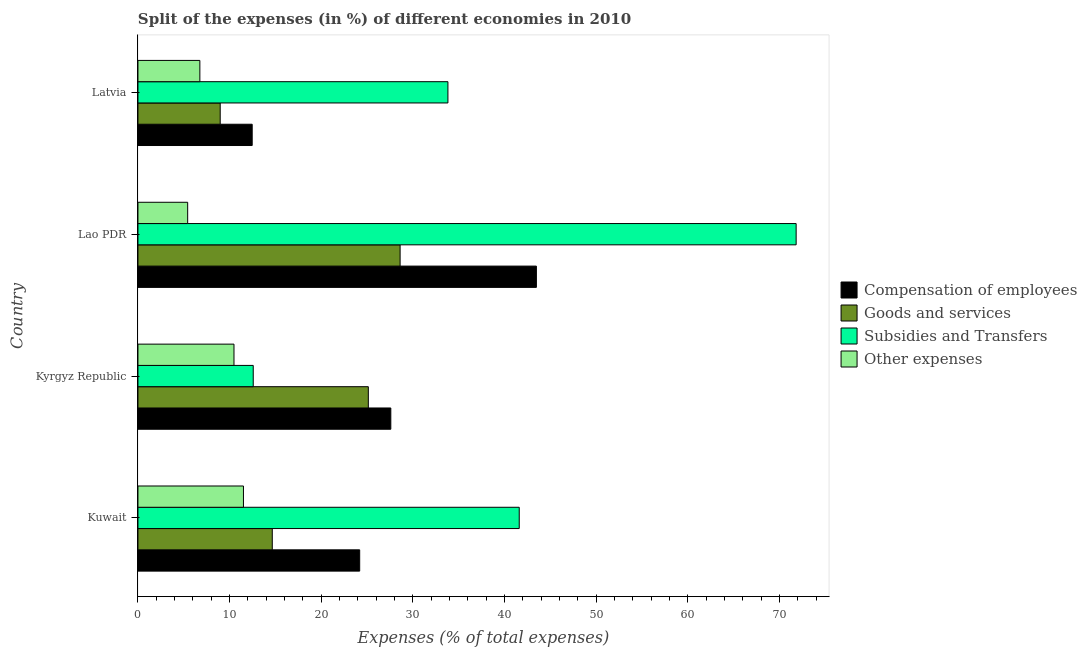How many groups of bars are there?
Provide a succinct answer. 4. Are the number of bars per tick equal to the number of legend labels?
Ensure brevity in your answer.  Yes. How many bars are there on the 3rd tick from the top?
Offer a very short reply. 4. How many bars are there on the 4th tick from the bottom?
Your response must be concise. 4. What is the label of the 4th group of bars from the top?
Provide a short and direct response. Kuwait. What is the percentage of amount spent on compensation of employees in Latvia?
Your answer should be very brief. 12.46. Across all countries, what is the maximum percentage of amount spent on goods and services?
Make the answer very short. 28.6. Across all countries, what is the minimum percentage of amount spent on compensation of employees?
Your answer should be very brief. 12.46. In which country was the percentage of amount spent on other expenses maximum?
Give a very brief answer. Kuwait. In which country was the percentage of amount spent on subsidies minimum?
Provide a short and direct response. Kyrgyz Republic. What is the total percentage of amount spent on other expenses in the graph?
Your answer should be very brief. 34.16. What is the difference between the percentage of amount spent on subsidies in Kyrgyz Republic and that in Lao PDR?
Provide a short and direct response. -59.23. What is the difference between the percentage of amount spent on other expenses in Kuwait and the percentage of amount spent on compensation of employees in Lao PDR?
Provide a short and direct response. -31.96. What is the average percentage of amount spent on goods and services per country?
Make the answer very short. 19.34. What is the difference between the percentage of amount spent on other expenses and percentage of amount spent on goods and services in Kyrgyz Republic?
Give a very brief answer. -14.66. What is the ratio of the percentage of amount spent on compensation of employees in Kyrgyz Republic to that in Lao PDR?
Keep it short and to the point. 0.64. Is the difference between the percentage of amount spent on subsidies in Kuwait and Latvia greater than the difference between the percentage of amount spent on other expenses in Kuwait and Latvia?
Provide a short and direct response. Yes. What is the difference between the highest and the second highest percentage of amount spent on compensation of employees?
Ensure brevity in your answer.  15.88. What is the difference between the highest and the lowest percentage of amount spent on goods and services?
Your response must be concise. 19.63. In how many countries, is the percentage of amount spent on other expenses greater than the average percentage of amount spent on other expenses taken over all countries?
Offer a terse response. 2. Is the sum of the percentage of amount spent on goods and services in Kuwait and Kyrgyz Republic greater than the maximum percentage of amount spent on compensation of employees across all countries?
Make the answer very short. No. What does the 4th bar from the top in Kyrgyz Republic represents?
Provide a short and direct response. Compensation of employees. What does the 4th bar from the bottom in Latvia represents?
Keep it short and to the point. Other expenses. How many countries are there in the graph?
Provide a succinct answer. 4. Are the values on the major ticks of X-axis written in scientific E-notation?
Your answer should be very brief. No. Does the graph contain grids?
Give a very brief answer. No. Where does the legend appear in the graph?
Provide a succinct answer. Center right. How are the legend labels stacked?
Offer a very short reply. Vertical. What is the title of the graph?
Give a very brief answer. Split of the expenses (in %) of different economies in 2010. What is the label or title of the X-axis?
Ensure brevity in your answer.  Expenses (% of total expenses). What is the label or title of the Y-axis?
Your answer should be very brief. Country. What is the Expenses (% of total expenses) of Compensation of employees in Kuwait?
Your response must be concise. 24.19. What is the Expenses (% of total expenses) in Goods and services in Kuwait?
Give a very brief answer. 14.65. What is the Expenses (% of total expenses) in Subsidies and Transfers in Kuwait?
Keep it short and to the point. 41.6. What is the Expenses (% of total expenses) in Other expenses in Kuwait?
Offer a very short reply. 11.51. What is the Expenses (% of total expenses) of Compensation of employees in Kyrgyz Republic?
Provide a succinct answer. 27.59. What is the Expenses (% of total expenses) in Goods and services in Kyrgyz Republic?
Your answer should be very brief. 25.13. What is the Expenses (% of total expenses) of Subsidies and Transfers in Kyrgyz Republic?
Provide a succinct answer. 12.58. What is the Expenses (% of total expenses) of Other expenses in Kyrgyz Republic?
Your answer should be compact. 10.48. What is the Expenses (% of total expenses) in Compensation of employees in Lao PDR?
Your answer should be very brief. 43.47. What is the Expenses (% of total expenses) of Goods and services in Lao PDR?
Give a very brief answer. 28.6. What is the Expenses (% of total expenses) of Subsidies and Transfers in Lao PDR?
Provide a succinct answer. 71.81. What is the Expenses (% of total expenses) of Other expenses in Lao PDR?
Offer a very short reply. 5.42. What is the Expenses (% of total expenses) in Compensation of employees in Latvia?
Offer a terse response. 12.46. What is the Expenses (% of total expenses) of Goods and services in Latvia?
Keep it short and to the point. 8.97. What is the Expenses (% of total expenses) in Subsidies and Transfers in Latvia?
Ensure brevity in your answer.  33.82. What is the Expenses (% of total expenses) in Other expenses in Latvia?
Give a very brief answer. 6.75. Across all countries, what is the maximum Expenses (% of total expenses) of Compensation of employees?
Offer a very short reply. 43.47. Across all countries, what is the maximum Expenses (% of total expenses) of Goods and services?
Your answer should be compact. 28.6. Across all countries, what is the maximum Expenses (% of total expenses) of Subsidies and Transfers?
Offer a very short reply. 71.81. Across all countries, what is the maximum Expenses (% of total expenses) in Other expenses?
Give a very brief answer. 11.51. Across all countries, what is the minimum Expenses (% of total expenses) of Compensation of employees?
Ensure brevity in your answer.  12.46. Across all countries, what is the minimum Expenses (% of total expenses) in Goods and services?
Make the answer very short. 8.97. Across all countries, what is the minimum Expenses (% of total expenses) in Subsidies and Transfers?
Give a very brief answer. 12.58. Across all countries, what is the minimum Expenses (% of total expenses) in Other expenses?
Give a very brief answer. 5.42. What is the total Expenses (% of total expenses) in Compensation of employees in the graph?
Offer a terse response. 107.71. What is the total Expenses (% of total expenses) in Goods and services in the graph?
Your answer should be very brief. 77.36. What is the total Expenses (% of total expenses) in Subsidies and Transfers in the graph?
Offer a terse response. 159.8. What is the total Expenses (% of total expenses) of Other expenses in the graph?
Give a very brief answer. 34.16. What is the difference between the Expenses (% of total expenses) of Compensation of employees in Kuwait and that in Kyrgyz Republic?
Offer a terse response. -3.4. What is the difference between the Expenses (% of total expenses) of Goods and services in Kuwait and that in Kyrgyz Republic?
Your answer should be compact. -10.48. What is the difference between the Expenses (% of total expenses) of Subsidies and Transfers in Kuwait and that in Kyrgyz Republic?
Your answer should be compact. 29.02. What is the difference between the Expenses (% of total expenses) of Other expenses in Kuwait and that in Kyrgyz Republic?
Keep it short and to the point. 1.03. What is the difference between the Expenses (% of total expenses) in Compensation of employees in Kuwait and that in Lao PDR?
Provide a succinct answer. -19.28. What is the difference between the Expenses (% of total expenses) in Goods and services in Kuwait and that in Lao PDR?
Ensure brevity in your answer.  -13.95. What is the difference between the Expenses (% of total expenses) of Subsidies and Transfers in Kuwait and that in Lao PDR?
Give a very brief answer. -30.21. What is the difference between the Expenses (% of total expenses) in Other expenses in Kuwait and that in Lao PDR?
Provide a short and direct response. 6.08. What is the difference between the Expenses (% of total expenses) in Compensation of employees in Kuwait and that in Latvia?
Your answer should be compact. 11.73. What is the difference between the Expenses (% of total expenses) of Goods and services in Kuwait and that in Latvia?
Your answer should be compact. 5.68. What is the difference between the Expenses (% of total expenses) in Subsidies and Transfers in Kuwait and that in Latvia?
Make the answer very short. 7.78. What is the difference between the Expenses (% of total expenses) in Other expenses in Kuwait and that in Latvia?
Your answer should be compact. 4.75. What is the difference between the Expenses (% of total expenses) of Compensation of employees in Kyrgyz Republic and that in Lao PDR?
Provide a short and direct response. -15.88. What is the difference between the Expenses (% of total expenses) of Goods and services in Kyrgyz Republic and that in Lao PDR?
Offer a very short reply. -3.47. What is the difference between the Expenses (% of total expenses) in Subsidies and Transfers in Kyrgyz Republic and that in Lao PDR?
Make the answer very short. -59.23. What is the difference between the Expenses (% of total expenses) in Other expenses in Kyrgyz Republic and that in Lao PDR?
Keep it short and to the point. 5.05. What is the difference between the Expenses (% of total expenses) in Compensation of employees in Kyrgyz Republic and that in Latvia?
Give a very brief answer. 15.12. What is the difference between the Expenses (% of total expenses) of Goods and services in Kyrgyz Republic and that in Latvia?
Your answer should be compact. 16.16. What is the difference between the Expenses (% of total expenses) of Subsidies and Transfers in Kyrgyz Republic and that in Latvia?
Your answer should be very brief. -21.24. What is the difference between the Expenses (% of total expenses) in Other expenses in Kyrgyz Republic and that in Latvia?
Your answer should be compact. 3.72. What is the difference between the Expenses (% of total expenses) of Compensation of employees in Lao PDR and that in Latvia?
Your response must be concise. 31.01. What is the difference between the Expenses (% of total expenses) of Goods and services in Lao PDR and that in Latvia?
Provide a short and direct response. 19.63. What is the difference between the Expenses (% of total expenses) of Subsidies and Transfers in Lao PDR and that in Latvia?
Ensure brevity in your answer.  37.99. What is the difference between the Expenses (% of total expenses) in Other expenses in Lao PDR and that in Latvia?
Offer a terse response. -1.33. What is the difference between the Expenses (% of total expenses) in Compensation of employees in Kuwait and the Expenses (% of total expenses) in Goods and services in Kyrgyz Republic?
Ensure brevity in your answer.  -0.94. What is the difference between the Expenses (% of total expenses) in Compensation of employees in Kuwait and the Expenses (% of total expenses) in Subsidies and Transfers in Kyrgyz Republic?
Provide a succinct answer. 11.61. What is the difference between the Expenses (% of total expenses) of Compensation of employees in Kuwait and the Expenses (% of total expenses) of Other expenses in Kyrgyz Republic?
Your answer should be compact. 13.71. What is the difference between the Expenses (% of total expenses) of Goods and services in Kuwait and the Expenses (% of total expenses) of Subsidies and Transfers in Kyrgyz Republic?
Offer a very short reply. 2.08. What is the difference between the Expenses (% of total expenses) of Goods and services in Kuwait and the Expenses (% of total expenses) of Other expenses in Kyrgyz Republic?
Ensure brevity in your answer.  4.18. What is the difference between the Expenses (% of total expenses) of Subsidies and Transfers in Kuwait and the Expenses (% of total expenses) of Other expenses in Kyrgyz Republic?
Give a very brief answer. 31.12. What is the difference between the Expenses (% of total expenses) of Compensation of employees in Kuwait and the Expenses (% of total expenses) of Goods and services in Lao PDR?
Offer a very short reply. -4.41. What is the difference between the Expenses (% of total expenses) of Compensation of employees in Kuwait and the Expenses (% of total expenses) of Subsidies and Transfers in Lao PDR?
Keep it short and to the point. -47.62. What is the difference between the Expenses (% of total expenses) of Compensation of employees in Kuwait and the Expenses (% of total expenses) of Other expenses in Lao PDR?
Make the answer very short. 18.77. What is the difference between the Expenses (% of total expenses) in Goods and services in Kuwait and the Expenses (% of total expenses) in Subsidies and Transfers in Lao PDR?
Your response must be concise. -57.15. What is the difference between the Expenses (% of total expenses) in Goods and services in Kuwait and the Expenses (% of total expenses) in Other expenses in Lao PDR?
Offer a terse response. 9.23. What is the difference between the Expenses (% of total expenses) of Subsidies and Transfers in Kuwait and the Expenses (% of total expenses) of Other expenses in Lao PDR?
Give a very brief answer. 36.17. What is the difference between the Expenses (% of total expenses) in Compensation of employees in Kuwait and the Expenses (% of total expenses) in Goods and services in Latvia?
Your response must be concise. 15.22. What is the difference between the Expenses (% of total expenses) of Compensation of employees in Kuwait and the Expenses (% of total expenses) of Subsidies and Transfers in Latvia?
Make the answer very short. -9.63. What is the difference between the Expenses (% of total expenses) in Compensation of employees in Kuwait and the Expenses (% of total expenses) in Other expenses in Latvia?
Your response must be concise. 17.44. What is the difference between the Expenses (% of total expenses) of Goods and services in Kuwait and the Expenses (% of total expenses) of Subsidies and Transfers in Latvia?
Provide a succinct answer. -19.16. What is the difference between the Expenses (% of total expenses) in Goods and services in Kuwait and the Expenses (% of total expenses) in Other expenses in Latvia?
Give a very brief answer. 7.9. What is the difference between the Expenses (% of total expenses) of Subsidies and Transfers in Kuwait and the Expenses (% of total expenses) of Other expenses in Latvia?
Provide a succinct answer. 34.84. What is the difference between the Expenses (% of total expenses) in Compensation of employees in Kyrgyz Republic and the Expenses (% of total expenses) in Goods and services in Lao PDR?
Offer a terse response. -1.01. What is the difference between the Expenses (% of total expenses) of Compensation of employees in Kyrgyz Republic and the Expenses (% of total expenses) of Subsidies and Transfers in Lao PDR?
Keep it short and to the point. -44.22. What is the difference between the Expenses (% of total expenses) in Compensation of employees in Kyrgyz Republic and the Expenses (% of total expenses) in Other expenses in Lao PDR?
Give a very brief answer. 22.16. What is the difference between the Expenses (% of total expenses) in Goods and services in Kyrgyz Republic and the Expenses (% of total expenses) in Subsidies and Transfers in Lao PDR?
Your answer should be compact. -46.67. What is the difference between the Expenses (% of total expenses) in Goods and services in Kyrgyz Republic and the Expenses (% of total expenses) in Other expenses in Lao PDR?
Make the answer very short. 19.71. What is the difference between the Expenses (% of total expenses) in Subsidies and Transfers in Kyrgyz Republic and the Expenses (% of total expenses) in Other expenses in Lao PDR?
Offer a terse response. 7.15. What is the difference between the Expenses (% of total expenses) of Compensation of employees in Kyrgyz Republic and the Expenses (% of total expenses) of Goods and services in Latvia?
Ensure brevity in your answer.  18.61. What is the difference between the Expenses (% of total expenses) in Compensation of employees in Kyrgyz Republic and the Expenses (% of total expenses) in Subsidies and Transfers in Latvia?
Ensure brevity in your answer.  -6.23. What is the difference between the Expenses (% of total expenses) in Compensation of employees in Kyrgyz Republic and the Expenses (% of total expenses) in Other expenses in Latvia?
Provide a short and direct response. 20.83. What is the difference between the Expenses (% of total expenses) of Goods and services in Kyrgyz Republic and the Expenses (% of total expenses) of Subsidies and Transfers in Latvia?
Your response must be concise. -8.68. What is the difference between the Expenses (% of total expenses) of Goods and services in Kyrgyz Republic and the Expenses (% of total expenses) of Other expenses in Latvia?
Your response must be concise. 18.38. What is the difference between the Expenses (% of total expenses) of Subsidies and Transfers in Kyrgyz Republic and the Expenses (% of total expenses) of Other expenses in Latvia?
Keep it short and to the point. 5.82. What is the difference between the Expenses (% of total expenses) in Compensation of employees in Lao PDR and the Expenses (% of total expenses) in Goods and services in Latvia?
Make the answer very short. 34.5. What is the difference between the Expenses (% of total expenses) in Compensation of employees in Lao PDR and the Expenses (% of total expenses) in Subsidies and Transfers in Latvia?
Offer a terse response. 9.65. What is the difference between the Expenses (% of total expenses) in Compensation of employees in Lao PDR and the Expenses (% of total expenses) in Other expenses in Latvia?
Your answer should be compact. 36.71. What is the difference between the Expenses (% of total expenses) in Goods and services in Lao PDR and the Expenses (% of total expenses) in Subsidies and Transfers in Latvia?
Provide a short and direct response. -5.22. What is the difference between the Expenses (% of total expenses) in Goods and services in Lao PDR and the Expenses (% of total expenses) in Other expenses in Latvia?
Keep it short and to the point. 21.85. What is the difference between the Expenses (% of total expenses) in Subsidies and Transfers in Lao PDR and the Expenses (% of total expenses) in Other expenses in Latvia?
Offer a very short reply. 65.05. What is the average Expenses (% of total expenses) in Compensation of employees per country?
Your response must be concise. 26.93. What is the average Expenses (% of total expenses) in Goods and services per country?
Offer a very short reply. 19.34. What is the average Expenses (% of total expenses) in Subsidies and Transfers per country?
Make the answer very short. 39.95. What is the average Expenses (% of total expenses) in Other expenses per country?
Offer a very short reply. 8.54. What is the difference between the Expenses (% of total expenses) of Compensation of employees and Expenses (% of total expenses) of Goods and services in Kuwait?
Ensure brevity in your answer.  9.54. What is the difference between the Expenses (% of total expenses) of Compensation of employees and Expenses (% of total expenses) of Subsidies and Transfers in Kuwait?
Keep it short and to the point. -17.41. What is the difference between the Expenses (% of total expenses) in Compensation of employees and Expenses (% of total expenses) in Other expenses in Kuwait?
Offer a very short reply. 12.68. What is the difference between the Expenses (% of total expenses) of Goods and services and Expenses (% of total expenses) of Subsidies and Transfers in Kuwait?
Give a very brief answer. -26.94. What is the difference between the Expenses (% of total expenses) of Goods and services and Expenses (% of total expenses) of Other expenses in Kuwait?
Give a very brief answer. 3.15. What is the difference between the Expenses (% of total expenses) of Subsidies and Transfers and Expenses (% of total expenses) of Other expenses in Kuwait?
Provide a short and direct response. 30.09. What is the difference between the Expenses (% of total expenses) in Compensation of employees and Expenses (% of total expenses) in Goods and services in Kyrgyz Republic?
Provide a short and direct response. 2.45. What is the difference between the Expenses (% of total expenses) of Compensation of employees and Expenses (% of total expenses) of Subsidies and Transfers in Kyrgyz Republic?
Ensure brevity in your answer.  15.01. What is the difference between the Expenses (% of total expenses) of Compensation of employees and Expenses (% of total expenses) of Other expenses in Kyrgyz Republic?
Your answer should be very brief. 17.11. What is the difference between the Expenses (% of total expenses) in Goods and services and Expenses (% of total expenses) in Subsidies and Transfers in Kyrgyz Republic?
Offer a very short reply. 12.56. What is the difference between the Expenses (% of total expenses) in Goods and services and Expenses (% of total expenses) in Other expenses in Kyrgyz Republic?
Give a very brief answer. 14.66. What is the difference between the Expenses (% of total expenses) of Subsidies and Transfers and Expenses (% of total expenses) of Other expenses in Kyrgyz Republic?
Give a very brief answer. 2.1. What is the difference between the Expenses (% of total expenses) of Compensation of employees and Expenses (% of total expenses) of Goods and services in Lao PDR?
Ensure brevity in your answer.  14.87. What is the difference between the Expenses (% of total expenses) of Compensation of employees and Expenses (% of total expenses) of Subsidies and Transfers in Lao PDR?
Make the answer very short. -28.34. What is the difference between the Expenses (% of total expenses) in Compensation of employees and Expenses (% of total expenses) in Other expenses in Lao PDR?
Ensure brevity in your answer.  38.04. What is the difference between the Expenses (% of total expenses) in Goods and services and Expenses (% of total expenses) in Subsidies and Transfers in Lao PDR?
Offer a very short reply. -43.21. What is the difference between the Expenses (% of total expenses) in Goods and services and Expenses (% of total expenses) in Other expenses in Lao PDR?
Offer a very short reply. 23.18. What is the difference between the Expenses (% of total expenses) of Subsidies and Transfers and Expenses (% of total expenses) of Other expenses in Lao PDR?
Provide a succinct answer. 66.38. What is the difference between the Expenses (% of total expenses) in Compensation of employees and Expenses (% of total expenses) in Goods and services in Latvia?
Ensure brevity in your answer.  3.49. What is the difference between the Expenses (% of total expenses) of Compensation of employees and Expenses (% of total expenses) of Subsidies and Transfers in Latvia?
Keep it short and to the point. -21.35. What is the difference between the Expenses (% of total expenses) of Compensation of employees and Expenses (% of total expenses) of Other expenses in Latvia?
Provide a succinct answer. 5.71. What is the difference between the Expenses (% of total expenses) in Goods and services and Expenses (% of total expenses) in Subsidies and Transfers in Latvia?
Keep it short and to the point. -24.84. What is the difference between the Expenses (% of total expenses) of Goods and services and Expenses (% of total expenses) of Other expenses in Latvia?
Keep it short and to the point. 2.22. What is the difference between the Expenses (% of total expenses) in Subsidies and Transfers and Expenses (% of total expenses) in Other expenses in Latvia?
Make the answer very short. 27.06. What is the ratio of the Expenses (% of total expenses) of Compensation of employees in Kuwait to that in Kyrgyz Republic?
Make the answer very short. 0.88. What is the ratio of the Expenses (% of total expenses) of Goods and services in Kuwait to that in Kyrgyz Republic?
Keep it short and to the point. 0.58. What is the ratio of the Expenses (% of total expenses) of Subsidies and Transfers in Kuwait to that in Kyrgyz Republic?
Ensure brevity in your answer.  3.31. What is the ratio of the Expenses (% of total expenses) in Other expenses in Kuwait to that in Kyrgyz Republic?
Offer a terse response. 1.1. What is the ratio of the Expenses (% of total expenses) of Compensation of employees in Kuwait to that in Lao PDR?
Make the answer very short. 0.56. What is the ratio of the Expenses (% of total expenses) of Goods and services in Kuwait to that in Lao PDR?
Make the answer very short. 0.51. What is the ratio of the Expenses (% of total expenses) in Subsidies and Transfers in Kuwait to that in Lao PDR?
Your response must be concise. 0.58. What is the ratio of the Expenses (% of total expenses) in Other expenses in Kuwait to that in Lao PDR?
Your answer should be compact. 2.12. What is the ratio of the Expenses (% of total expenses) of Compensation of employees in Kuwait to that in Latvia?
Offer a very short reply. 1.94. What is the ratio of the Expenses (% of total expenses) in Goods and services in Kuwait to that in Latvia?
Your answer should be very brief. 1.63. What is the ratio of the Expenses (% of total expenses) of Subsidies and Transfers in Kuwait to that in Latvia?
Your answer should be compact. 1.23. What is the ratio of the Expenses (% of total expenses) in Other expenses in Kuwait to that in Latvia?
Keep it short and to the point. 1.7. What is the ratio of the Expenses (% of total expenses) in Compensation of employees in Kyrgyz Republic to that in Lao PDR?
Offer a very short reply. 0.63. What is the ratio of the Expenses (% of total expenses) in Goods and services in Kyrgyz Republic to that in Lao PDR?
Provide a short and direct response. 0.88. What is the ratio of the Expenses (% of total expenses) in Subsidies and Transfers in Kyrgyz Republic to that in Lao PDR?
Make the answer very short. 0.18. What is the ratio of the Expenses (% of total expenses) of Other expenses in Kyrgyz Republic to that in Lao PDR?
Offer a very short reply. 1.93. What is the ratio of the Expenses (% of total expenses) in Compensation of employees in Kyrgyz Republic to that in Latvia?
Your answer should be compact. 2.21. What is the ratio of the Expenses (% of total expenses) of Goods and services in Kyrgyz Republic to that in Latvia?
Keep it short and to the point. 2.8. What is the ratio of the Expenses (% of total expenses) in Subsidies and Transfers in Kyrgyz Republic to that in Latvia?
Your response must be concise. 0.37. What is the ratio of the Expenses (% of total expenses) in Other expenses in Kyrgyz Republic to that in Latvia?
Your response must be concise. 1.55. What is the ratio of the Expenses (% of total expenses) of Compensation of employees in Lao PDR to that in Latvia?
Offer a terse response. 3.49. What is the ratio of the Expenses (% of total expenses) in Goods and services in Lao PDR to that in Latvia?
Ensure brevity in your answer.  3.19. What is the ratio of the Expenses (% of total expenses) of Subsidies and Transfers in Lao PDR to that in Latvia?
Your answer should be very brief. 2.12. What is the ratio of the Expenses (% of total expenses) of Other expenses in Lao PDR to that in Latvia?
Your response must be concise. 0.8. What is the difference between the highest and the second highest Expenses (% of total expenses) of Compensation of employees?
Ensure brevity in your answer.  15.88. What is the difference between the highest and the second highest Expenses (% of total expenses) in Goods and services?
Provide a succinct answer. 3.47. What is the difference between the highest and the second highest Expenses (% of total expenses) in Subsidies and Transfers?
Keep it short and to the point. 30.21. What is the difference between the highest and the second highest Expenses (% of total expenses) of Other expenses?
Provide a short and direct response. 1.03. What is the difference between the highest and the lowest Expenses (% of total expenses) in Compensation of employees?
Provide a short and direct response. 31.01. What is the difference between the highest and the lowest Expenses (% of total expenses) of Goods and services?
Ensure brevity in your answer.  19.63. What is the difference between the highest and the lowest Expenses (% of total expenses) of Subsidies and Transfers?
Provide a succinct answer. 59.23. What is the difference between the highest and the lowest Expenses (% of total expenses) of Other expenses?
Give a very brief answer. 6.08. 